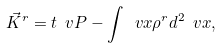Convert formula to latex. <formula><loc_0><loc_0><loc_500><loc_500>\vec { K } ^ { r } = t \ v P - \int \ v x \rho ^ { r } d ^ { 2 } \ v x ,</formula> 